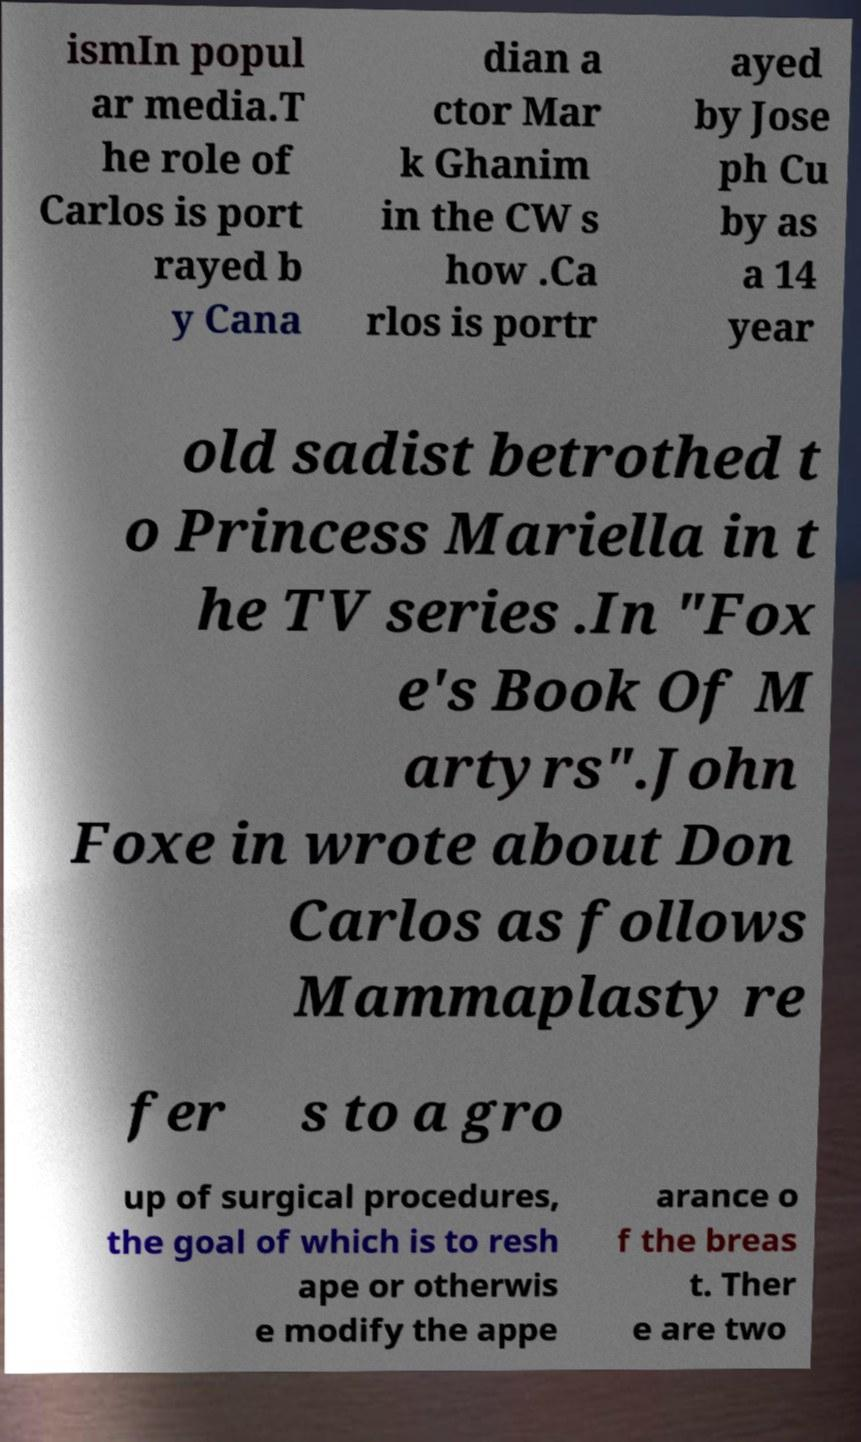What messages or text are displayed in this image? I need them in a readable, typed format. ismIn popul ar media.T he role of Carlos is port rayed b y Cana dian a ctor Mar k Ghanim in the CW s how .Ca rlos is portr ayed by Jose ph Cu by as a 14 year old sadist betrothed t o Princess Mariella in t he TV series .In "Fox e's Book Of M artyrs".John Foxe in wrote about Don Carlos as follows Mammaplasty re fer s to a gro up of surgical procedures, the goal of which is to resh ape or otherwis e modify the appe arance o f the breas t. Ther e are two 